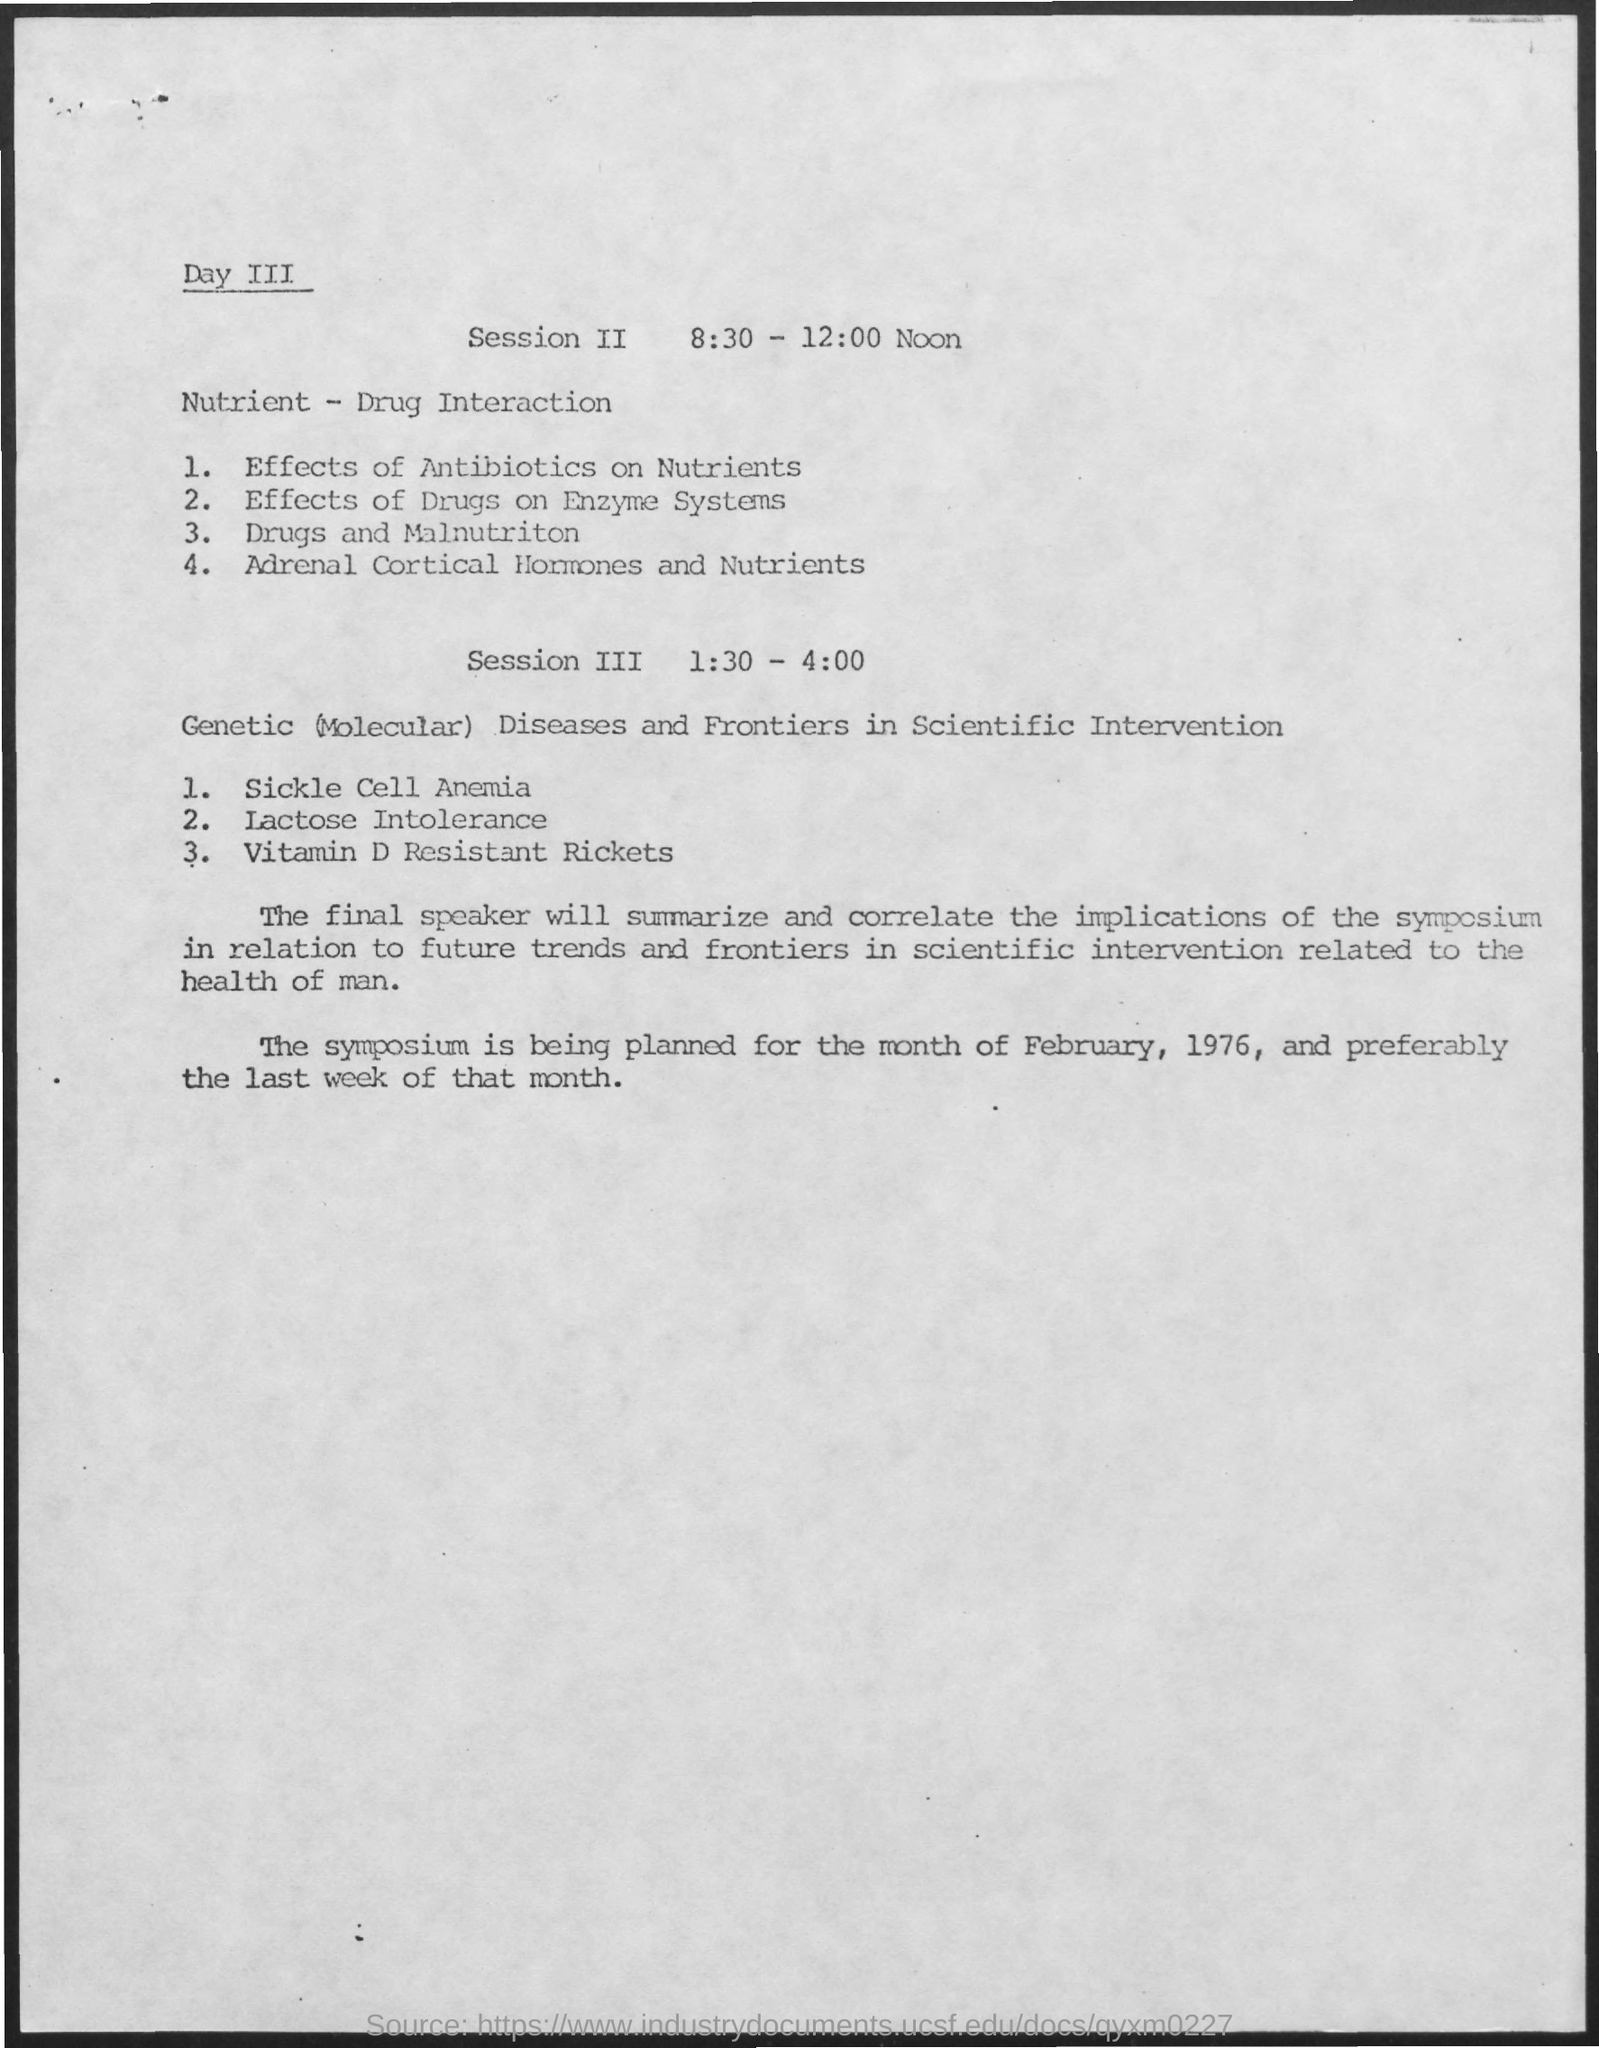Specify some key components in this picture. During session two on day three, the subject of discussion was nutrient-drug interactions. 